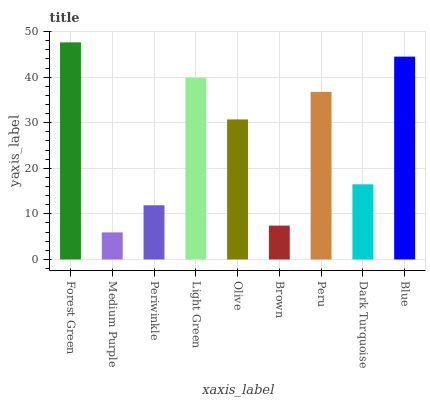Is Forest Green the maximum?
Answer yes or no. Yes. Is Periwinkle the minimum?
Answer yes or no. No. Is Periwinkle the maximum?
Answer yes or no. No. Is Periwinkle greater than Medium Purple?
Answer yes or no. Yes. Is Medium Purple less than Periwinkle?
Answer yes or no. Yes. Is Medium Purple greater than Periwinkle?
Answer yes or no. No. Is Periwinkle less than Medium Purple?
Answer yes or no. No. Is Olive the high median?
Answer yes or no. Yes. Is Olive the low median?
Answer yes or no. Yes. Is Blue the high median?
Answer yes or no. No. Is Medium Purple the low median?
Answer yes or no. No. 